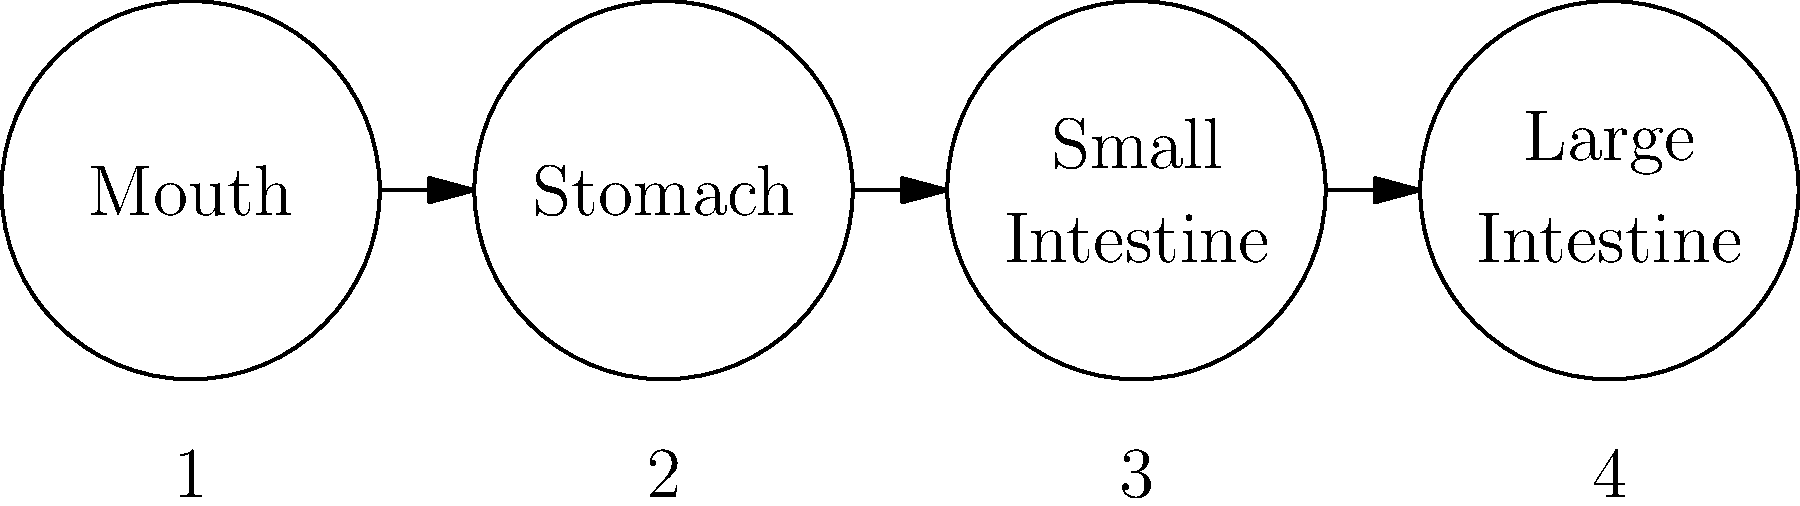Identify the correct sequence of images showing the digestion process of dairy products in the human body. The digestion process of dairy products follows these steps:

1. Mouth: Dairy products enter the digestive system through the mouth. Here, mechanical breakdown begins through chewing, and enzymes in saliva start the initial chemical breakdown of lactose.

2. Stomach: The dairy products move to the stomach, where they are mixed with gastric juices. The acidic environment of the stomach begins to break down proteins in the dairy products.

3. Small Intestine: Most of the digestion and absorption of dairy products occurs here. Enzymes like lactase break down lactose into simpler sugars. Proteins are further broken down into amino acids, and fats are emulsified by bile and broken down by lipases.

4. Large Intestine: Any undigested dairy components enter the large intestine. Here, water is absorbed, and some fermentation of undigested lactose may occur by gut bacteria.

The correct sequence follows the natural flow of the digestive system: Mouth → Stomach → Small Intestine → Large Intestine, which corresponds to the order 1 → 2 → 3 → 4 in the diagram.
Answer: 1 → 2 → 3 → 4 